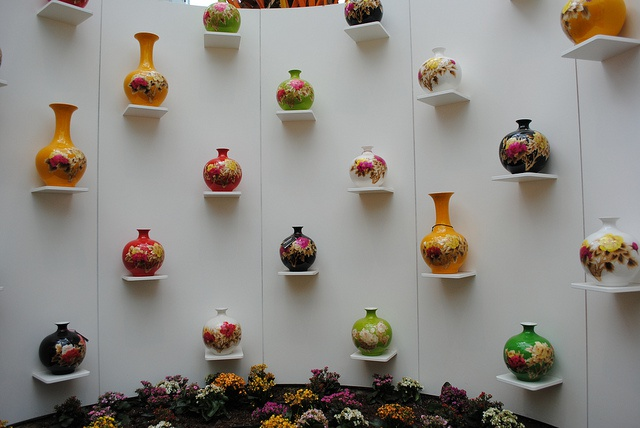Describe the objects in this image and their specific colors. I can see vase in gray, darkgray, black, olive, and maroon tones, vase in gray, darkgray, maroon, and tan tones, vase in gray, brown, maroon, tan, and orange tones, vase in gray, brown, maroon, orange, and black tones, and vase in gray, black, darkgreen, olive, and maroon tones in this image. 